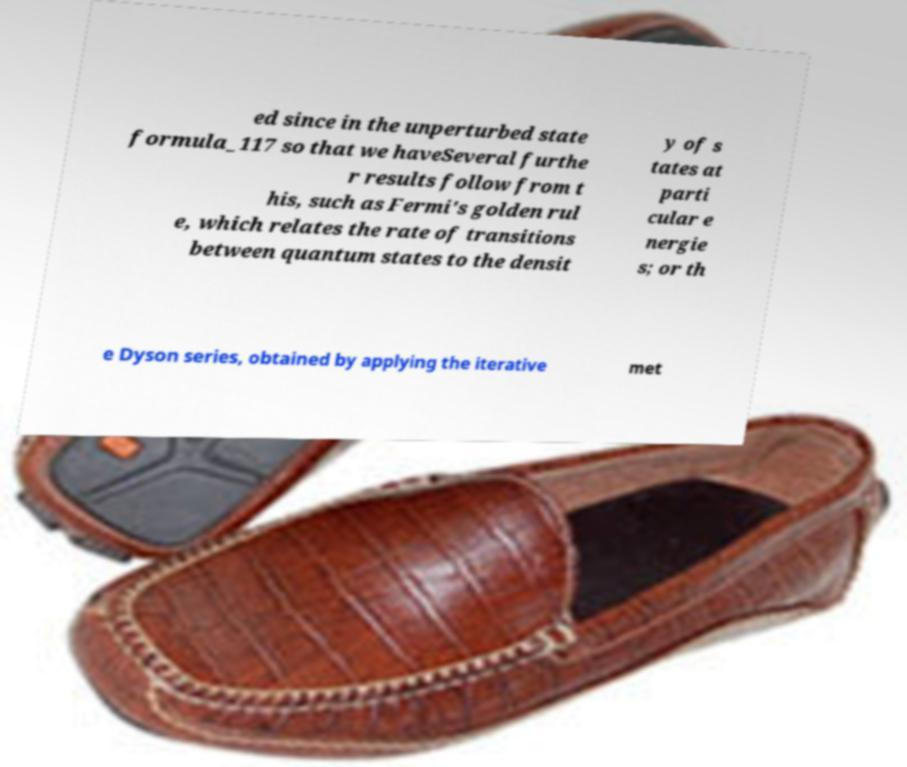Could you extract and type out the text from this image? ed since in the unperturbed state formula_117 so that we haveSeveral furthe r results follow from t his, such as Fermi's golden rul e, which relates the rate of transitions between quantum states to the densit y of s tates at parti cular e nergie s; or th e Dyson series, obtained by applying the iterative met 